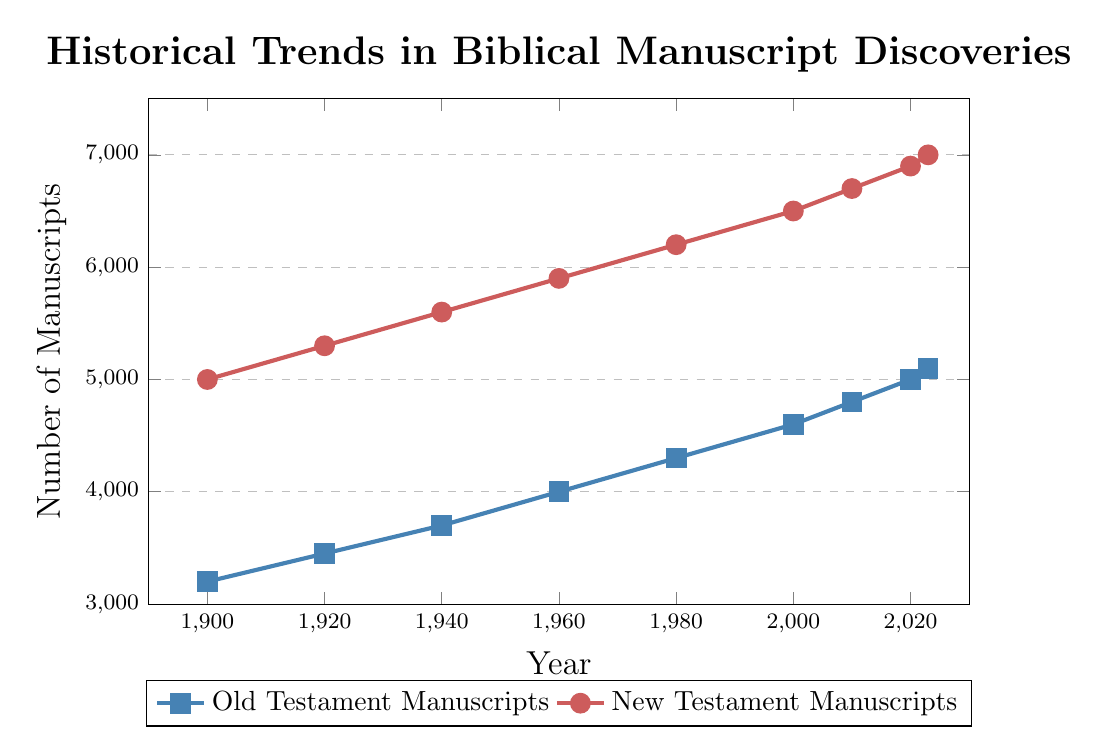What is the overall trend in the number of Old Testament manuscripts from 1900 to 2023? The number of Old Testament manuscripts increases steadily over time from 3200 in 1900 to 5100 in 2023. This indicates a consistent growth in manuscript discoveries.
Answer: Steady increase Between 1960 and 2000, how many more New Testament manuscripts were discovered compared to Old Testament manuscripts? In 1960, there were 5900 New Testament manuscripts and 4000 Old Testament manuscripts, a difference of 1900 manuscripts. In 2000, there were 6500 New Testament manuscripts and 4600 Old Testament manuscripts, a difference of 1900 manuscripts. Comparing these two periods: 6500 - 4600 = 1900 for New Testament, and 5900 - 4000 = 1900 for Old Testament. Therefore, the difference is the same.
Answer: 0 Which period saw the largest increase in New Testament manuscripts? The period from 1920 to 1940 went from 5300 to 5600 New Testament manuscripts, an increase of 300. The period from 1960 to 1980 went from 5900 to 6200, an increase of 300. From 2000 to 2020, it went from 6500 to 6900, an increase of 400, which is the most significant increase.
Answer: 2000 to 2020 By how much did the number of Old Testament manuscripts increase between 2010 and 2023? In 2010, there were 4800 Old Testament manuscripts. In 2023, there were 5100. The increase is calculated as 5100 - 4800.
Answer: 300 How many more New Testament manuscripts are there compared to Old Testament manuscripts in 2023? In 2023, there are 7000 New Testament manuscripts and 5100 Old Testament manuscripts. The difference is 7000 - 5100.
Answer: 1900 What is the average number of Old Testament manuscripts for the given years? Sum the number of Old Testament manuscripts for all given years: 3200 + 3450 + 3700 + 4000 + 4300 + 4600 + 4800 + 5000 + 5100 = 38150. There are 9 years in total. The average is calculated as 38150 / 9.
Answer: 4239 Compare the rate of discovery of Old Testament manuscripts to New Testament manuscripts from 1900 to 1960. In 1900, there were 3200 Old Testament and 5000 New Testament manuscripts. By 1960, it was 4000 Old Testament and 5900 New Testament manuscripts. The Old Testament increased by 4000 - 3200 = 800 manuscripts; the New Testament increased by 5900 - 5000 = 900 manuscripts. Therefore, the New Testament discovery rate was slightly higher.
Answer: New Testament higher Which manuscript type has a higher growth rate from 2000 to 2023? In 2000, there were 4600 Old Testament manuscripts and 6500 New Testament manuscripts. By 2023, there were 5100 Old Testament and 7000 New Testament manuscripts. For Old Testament: (5100 - 4600) / 4600 = 0.1087 (10.87%). For New Testament: (7000 - 6500) / 6500 = 0.0769 (7.69%). Hence, the Old Testament growth rate is higher.
Answer: Old Testament What visual differences can you observe between the trends for Old and New Testament manuscripts? The Old Testament manuscript line (blue) shows a more consistent, steady growth without major spikes, while the New Testament manuscript line (red) shows periods of more accelerated growth. This can be seen in the sharper increases in certain periods for the New Testament manuscripts.
Answer: Consistent vs. Accelerated What is the total number of New Testament manuscripts discovered from 1900 to 2023 according to the figure? Add up all the New Testament manuscripts counts from the given years: 5000 + 5300 + 5600 + 5900 + 6200 + 6500 + 6700 + 6900 + 7000 = 51100 manuscripts.
Answer: 51100 